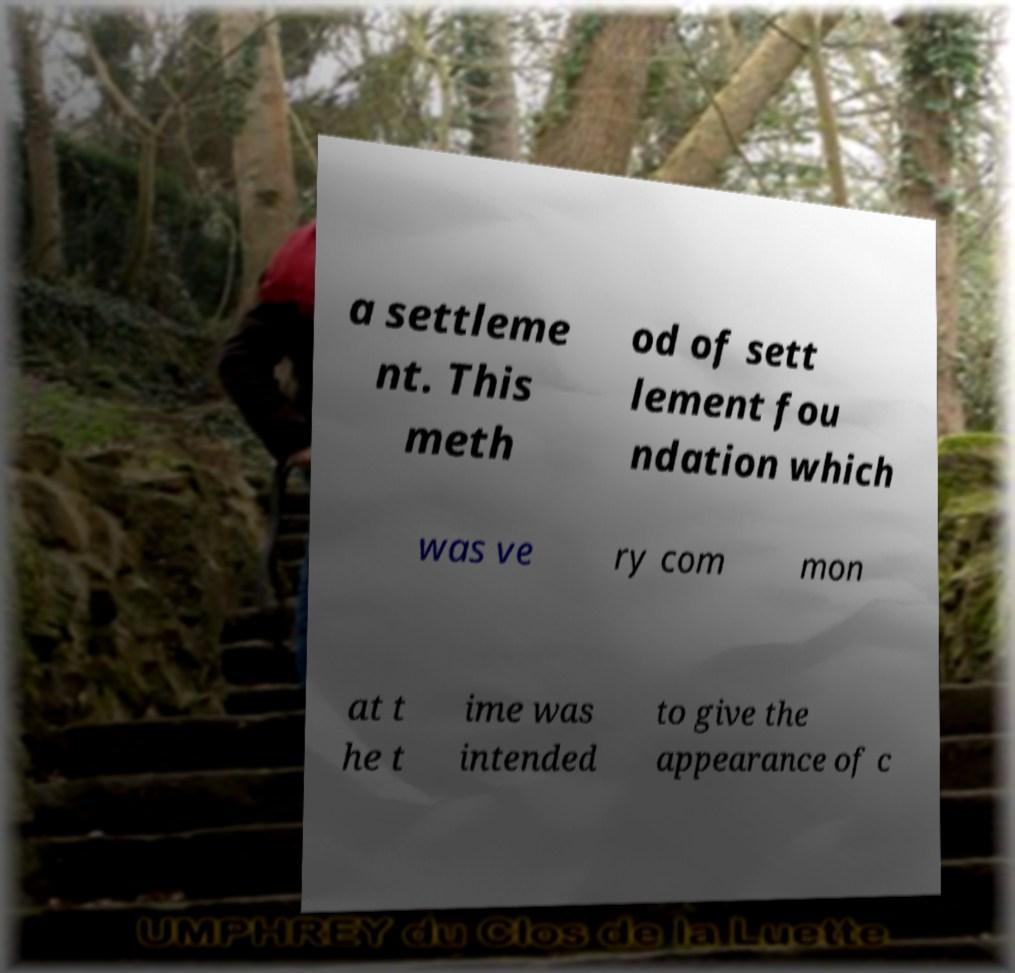Please identify and transcribe the text found in this image. a settleme nt. This meth od of sett lement fou ndation which was ve ry com mon at t he t ime was intended to give the appearance of c 